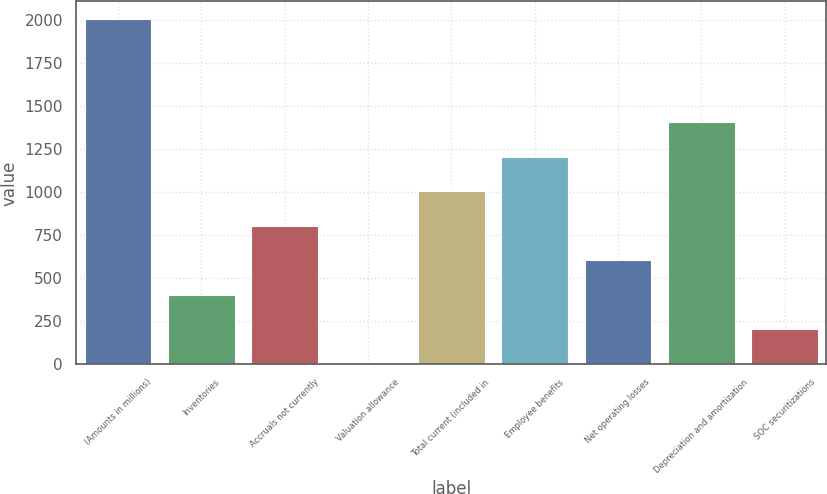<chart> <loc_0><loc_0><loc_500><loc_500><bar_chart><fcel>(Amounts in millions)<fcel>Inventories<fcel>Accruals not currently<fcel>Valuation allowance<fcel>Total current (included in<fcel>Employee benefits<fcel>Net operating losses<fcel>Depreciation and amortization<fcel>SOC securitizations<nl><fcel>2010<fcel>404.56<fcel>805.92<fcel>3.2<fcel>1006.6<fcel>1207.28<fcel>605.24<fcel>1407.96<fcel>203.88<nl></chart> 